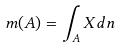<formula> <loc_0><loc_0><loc_500><loc_500>m ( A ) = \int _ { A } X d n</formula> 